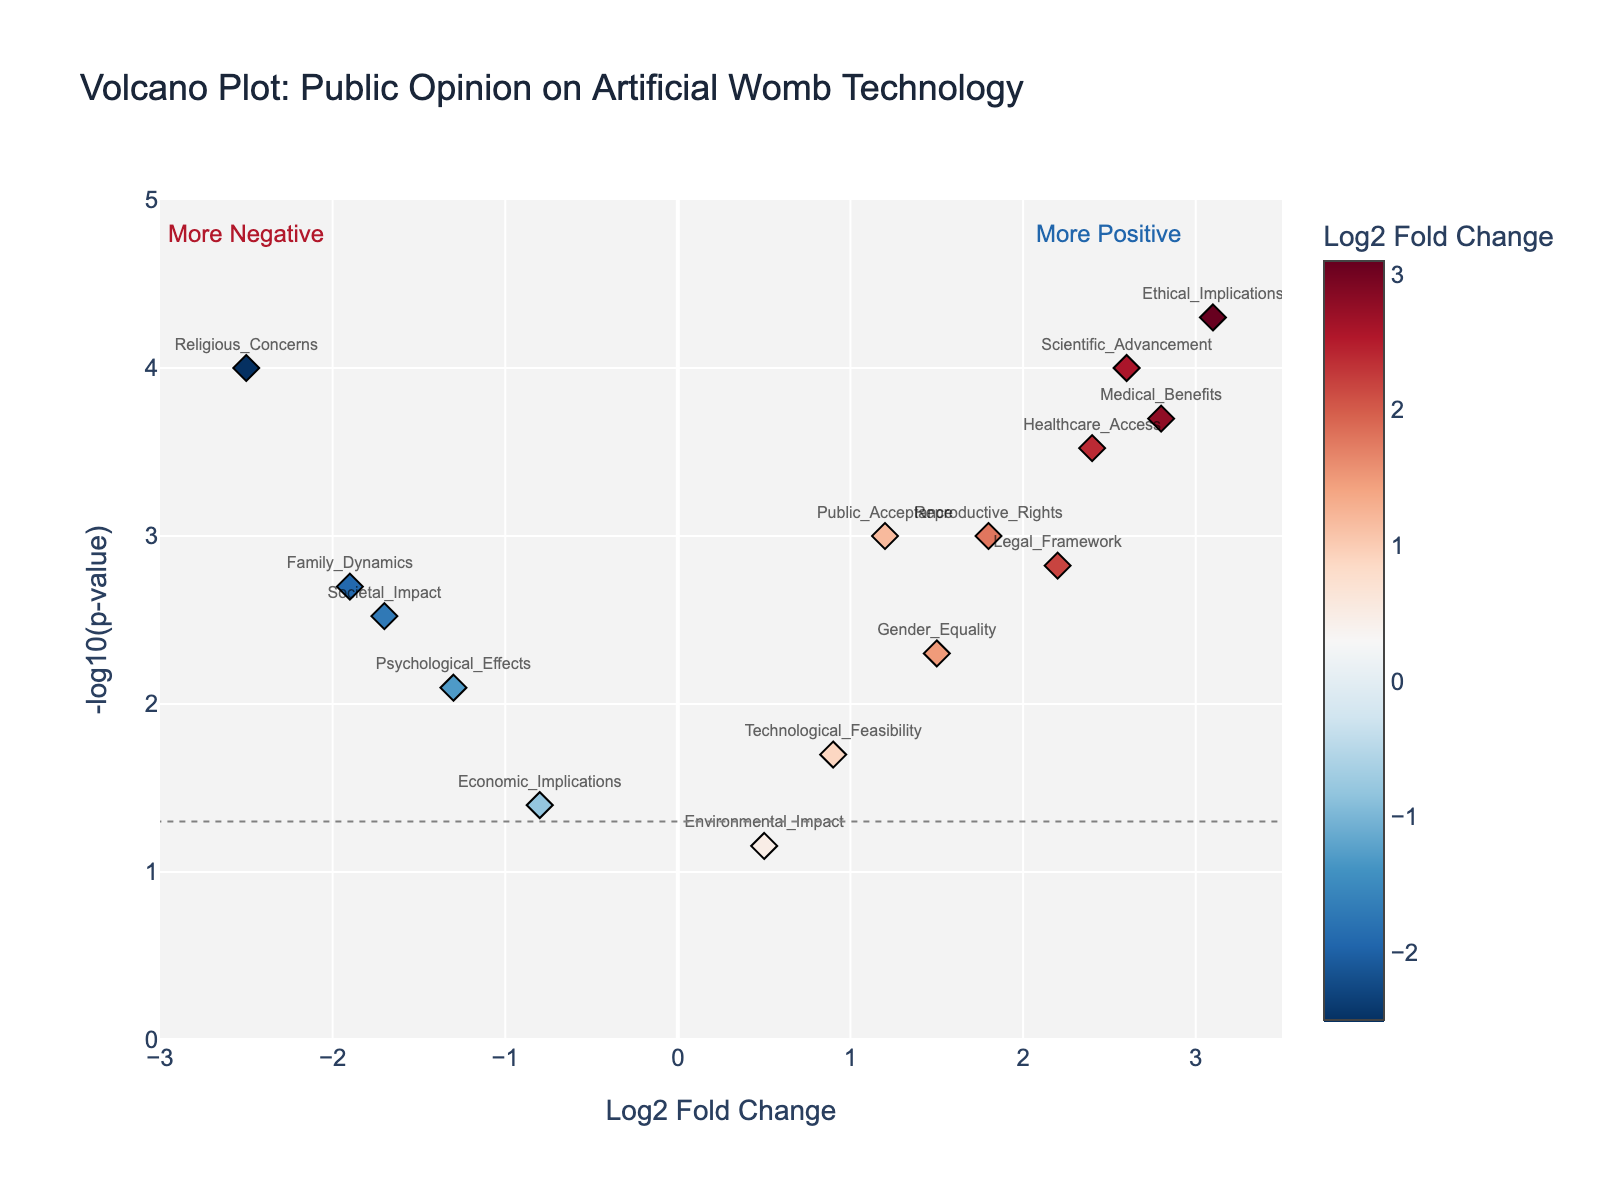What is the title of the figure? The title is usually located at the top of the figure. It provides a summary of what the figure is about.
Answer: Volcano Plot: Public Opinion on Artificial Womb Technology What does the x-axis represent? Observing the x-axis label provides information about what it measures.
Answer: Log2 Fold Change How many data points have Log2 Fold Change values greater than 2? By looking at the plot, count the number of data points on the right side of the x-axis where the Log2 Fold Change is greater than 2.
Answer: 4 Which data point has the highest -log10(p-value)? To identify this, find the point that is positioned the highest on the y-axis.
Answer: Ethical_Implications What is the Log2 Fold Change of the data point "Reproductive Rights"? Locate the "Reproductive Rights" data point in the figure and read its x-axis value.
Answer: 1.8 Which data point represents the most statistically significant negative opinion about artificial wombs? The most statistically significant negative opinion has the smallest p-value (highest -log10(p-value)) and a negative Log2 Fold Change.
Answer: Religious_Concerns How many data points have a p-value less than 0.05 but a Log2 Fold Change close to zero (between -0.5 and 0.5)? Count the data points that satisfy both conditions by their positions on the x-axis and y-axis.
Answer: None Which data points have a positive Log2 Fold Change and a p-value less than 0.002? Identify the points to the right of the y-axis with -log10(p-value) greater than or equal to -log10(0.002).
Answer: Public_Acceptance, Medical_Benefits, Legal_Framework, Healthcare_Access, Scientific_Advancement, Reproductive_Rights 